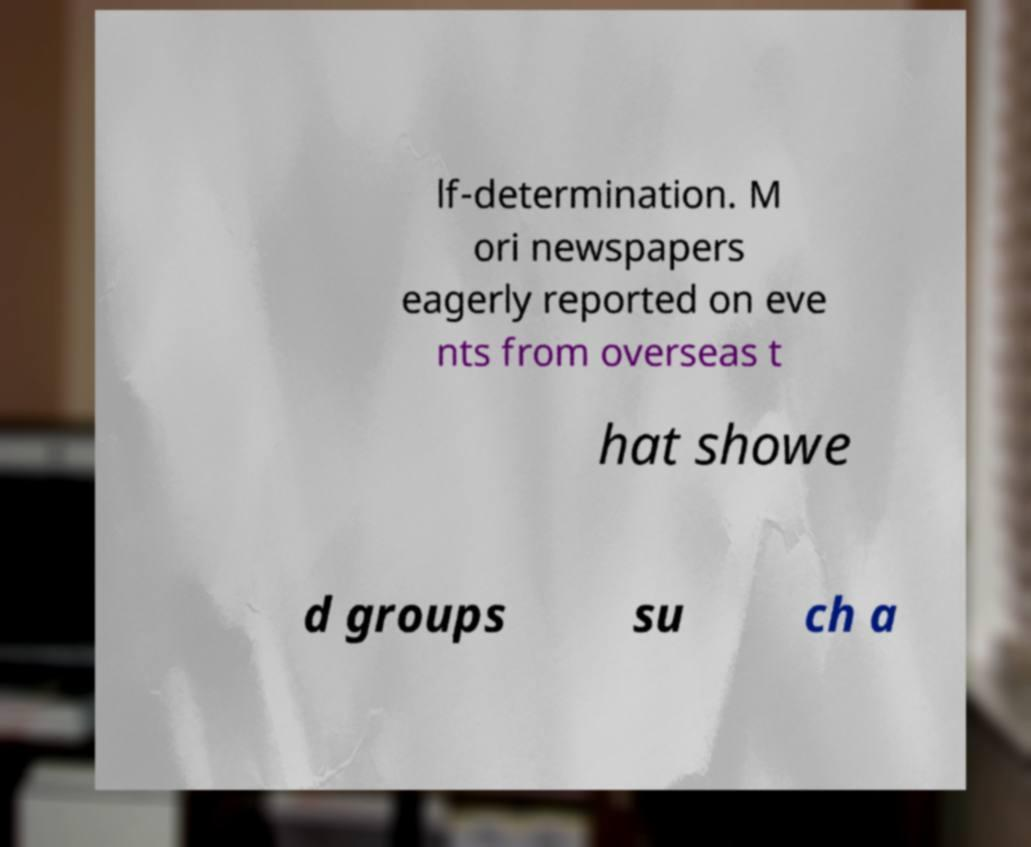Can you accurately transcribe the text from the provided image for me? lf-determination. M ori newspapers eagerly reported on eve nts from overseas t hat showe d groups su ch a 